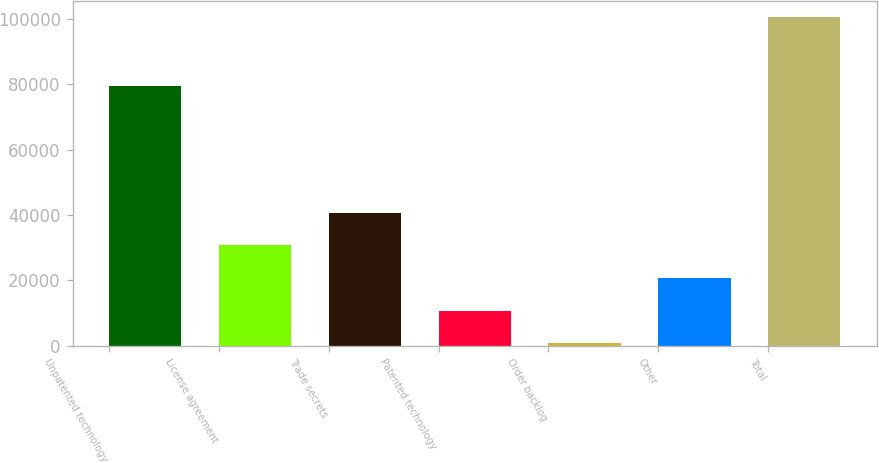Convert chart. <chart><loc_0><loc_0><loc_500><loc_500><bar_chart><fcel>Unpatented technology<fcel>License agreement<fcel>Trade secrets<fcel>Patented technology<fcel>Order backlog<fcel>Other<fcel>Total<nl><fcel>79500<fcel>30642.6<fcel>40616.8<fcel>10694.2<fcel>720<fcel>20668.4<fcel>100462<nl></chart> 